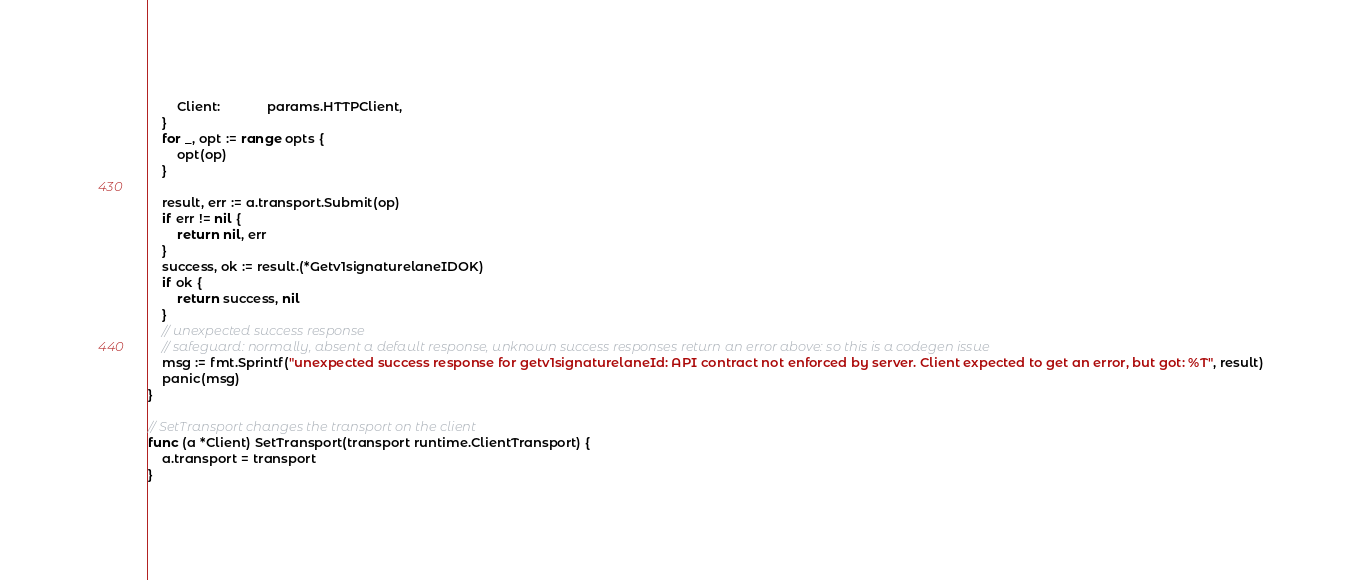Convert code to text. <code><loc_0><loc_0><loc_500><loc_500><_Go_>		Client:             params.HTTPClient,
	}
	for _, opt := range opts {
		opt(op)
	}

	result, err := a.transport.Submit(op)
	if err != nil {
		return nil, err
	}
	success, ok := result.(*Getv1signaturelaneIDOK)
	if ok {
		return success, nil
	}
	// unexpected success response
	// safeguard: normally, absent a default response, unknown success responses return an error above: so this is a codegen issue
	msg := fmt.Sprintf("unexpected success response for getv1signaturelaneId: API contract not enforced by server. Client expected to get an error, but got: %T", result)
	panic(msg)
}

// SetTransport changes the transport on the client
func (a *Client) SetTransport(transport runtime.ClientTransport) {
	a.transport = transport
}
</code> 